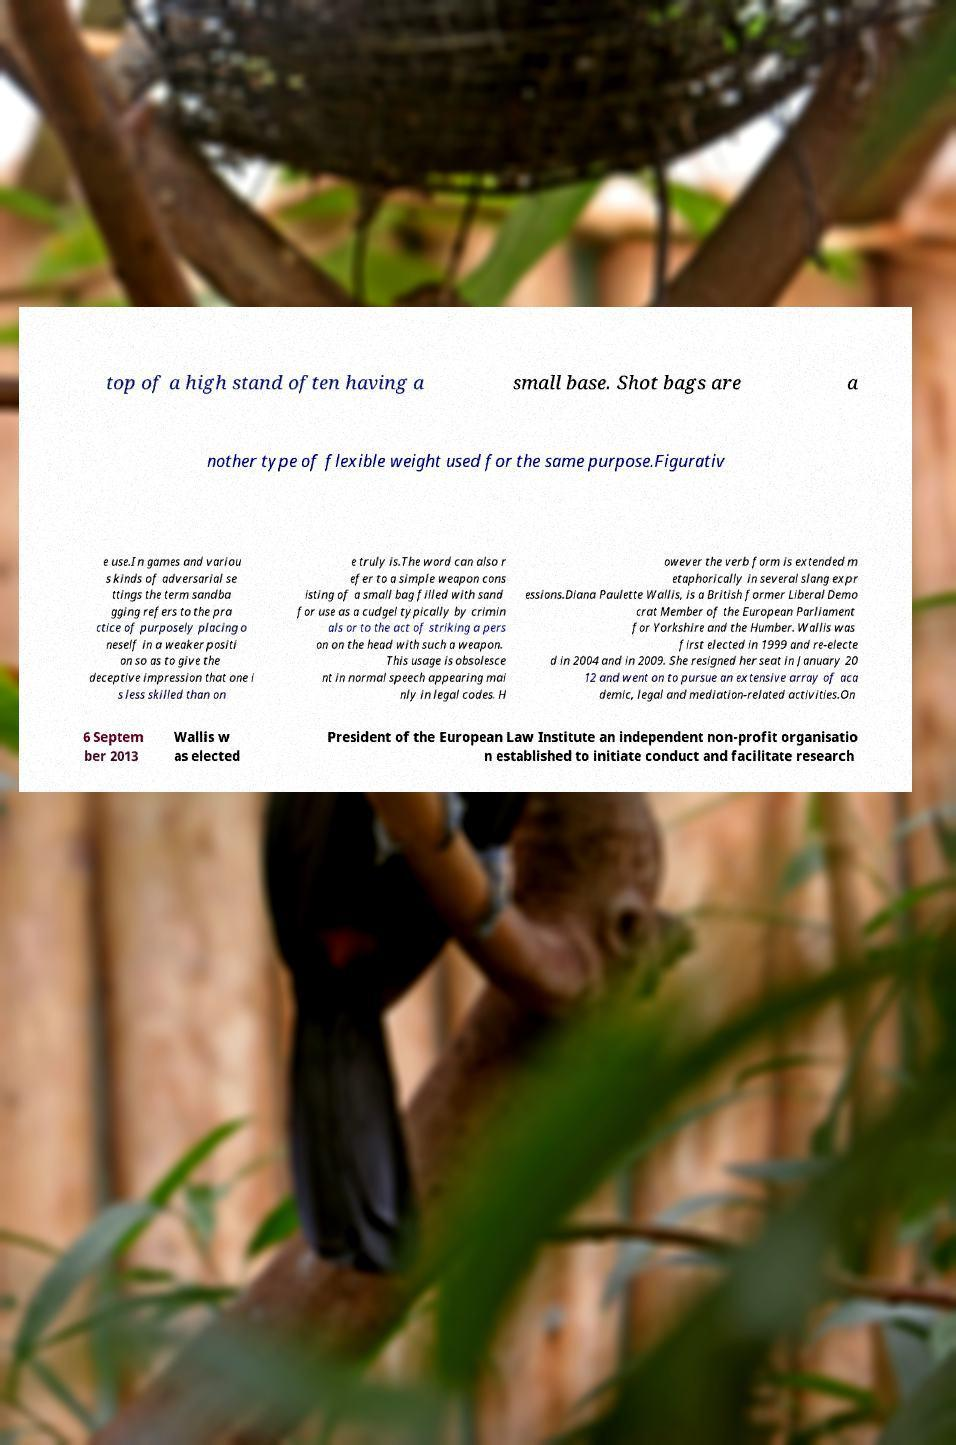What messages or text are displayed in this image? I need them in a readable, typed format. top of a high stand often having a small base. Shot bags are a nother type of flexible weight used for the same purpose.Figurativ e use.In games and variou s kinds of adversarial se ttings the term sandba gging refers to the pra ctice of purposely placing o neself in a weaker positi on so as to give the deceptive impression that one i s less skilled than on e truly is.The word can also r efer to a simple weapon cons isting of a small bag filled with sand for use as a cudgel typically by crimin als or to the act of striking a pers on on the head with such a weapon. This usage is obsolesce nt in normal speech appearing mai nly in legal codes. H owever the verb form is extended m etaphorically in several slang expr essions.Diana Paulette Wallis, is a British former Liberal Demo crat Member of the European Parliament for Yorkshire and the Humber. Wallis was first elected in 1999 and re-electe d in 2004 and in 2009. She resigned her seat in January 20 12 and went on to pursue an extensive array of aca demic, legal and mediation-related activities.On 6 Septem ber 2013 Wallis w as elected President of the European Law Institute an independent non-profit organisatio n established to initiate conduct and facilitate research 